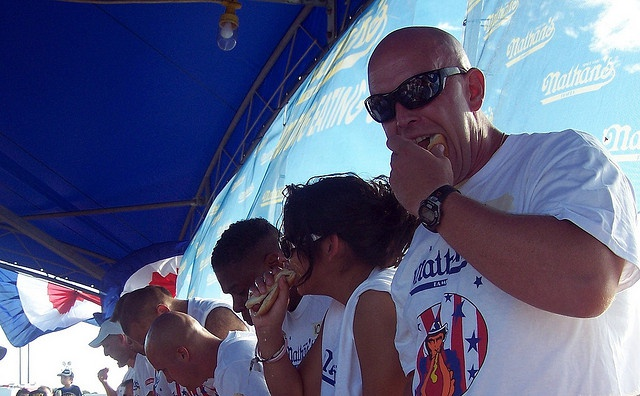Describe the objects in this image and their specific colors. I can see people in navy, purple, gray, and darkgray tones, people in navy, black, maroon, and gray tones, people in navy, black, and gray tones, people in navy, black, and white tones, and people in navy, black, brown, and gray tones in this image. 